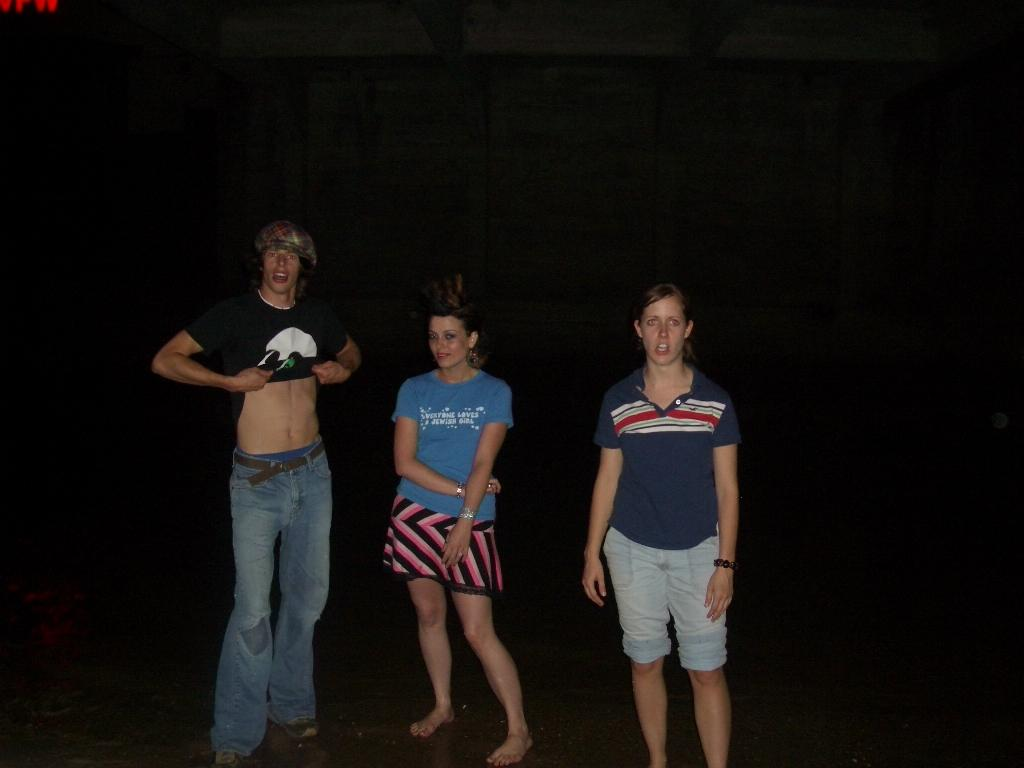How many people are in the image? There are three persons in the image. What are the persons doing in the image? The persons have their mouths open. Can you describe the lighting in the image? The image appears to be very dark. What type of bean is visible on the person's shirt in the image? There is no bean visible on any person's shirt in the image. What type of button can be seen on the person's jacket in the image? There is no jacket or button present in the image. 